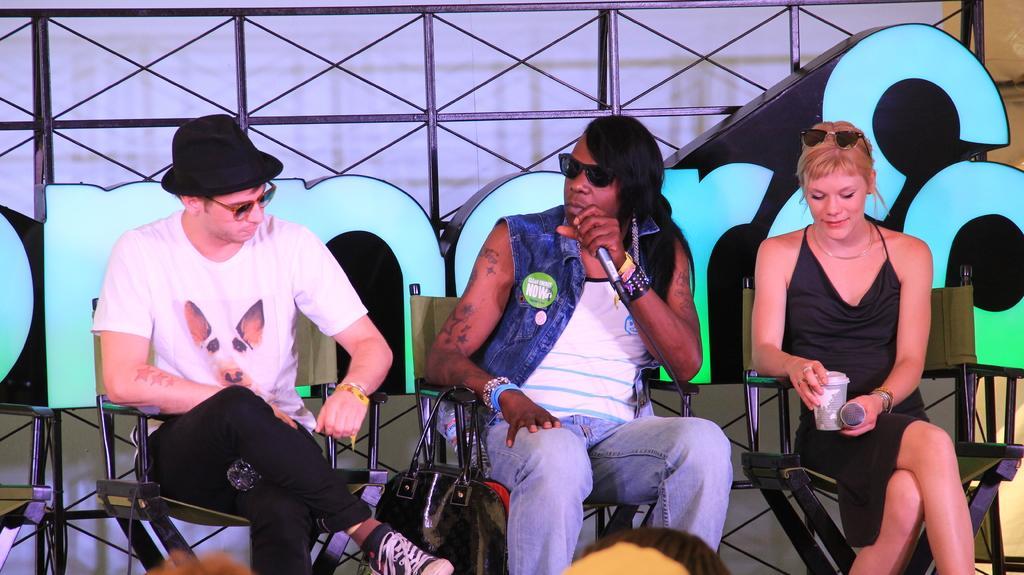How would you summarize this image in a sentence or two? In the center of the image we can see three people sitting on the chairs. The person sitting in the center is holding a mic. On the right there is a lady holding a mic and a glass. In the background there is a mesh. 